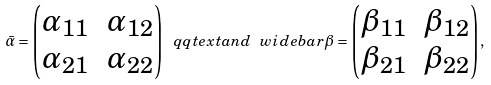Convert formula to latex. <formula><loc_0><loc_0><loc_500><loc_500>\bar { \alpha } = \begin{pmatrix} \alpha _ { 1 1 } & \alpha _ { 1 2 } \\ \alpha _ { 2 1 } & \alpha _ { 2 2 } \end{pmatrix} \ q q t e x t { a n d } \ w i d e b a r { \beta } = \begin{pmatrix} \beta _ { 1 1 } & \beta _ { 1 2 } \\ \beta _ { 2 1 } & \beta _ { 2 2 } \end{pmatrix} ,</formula> 